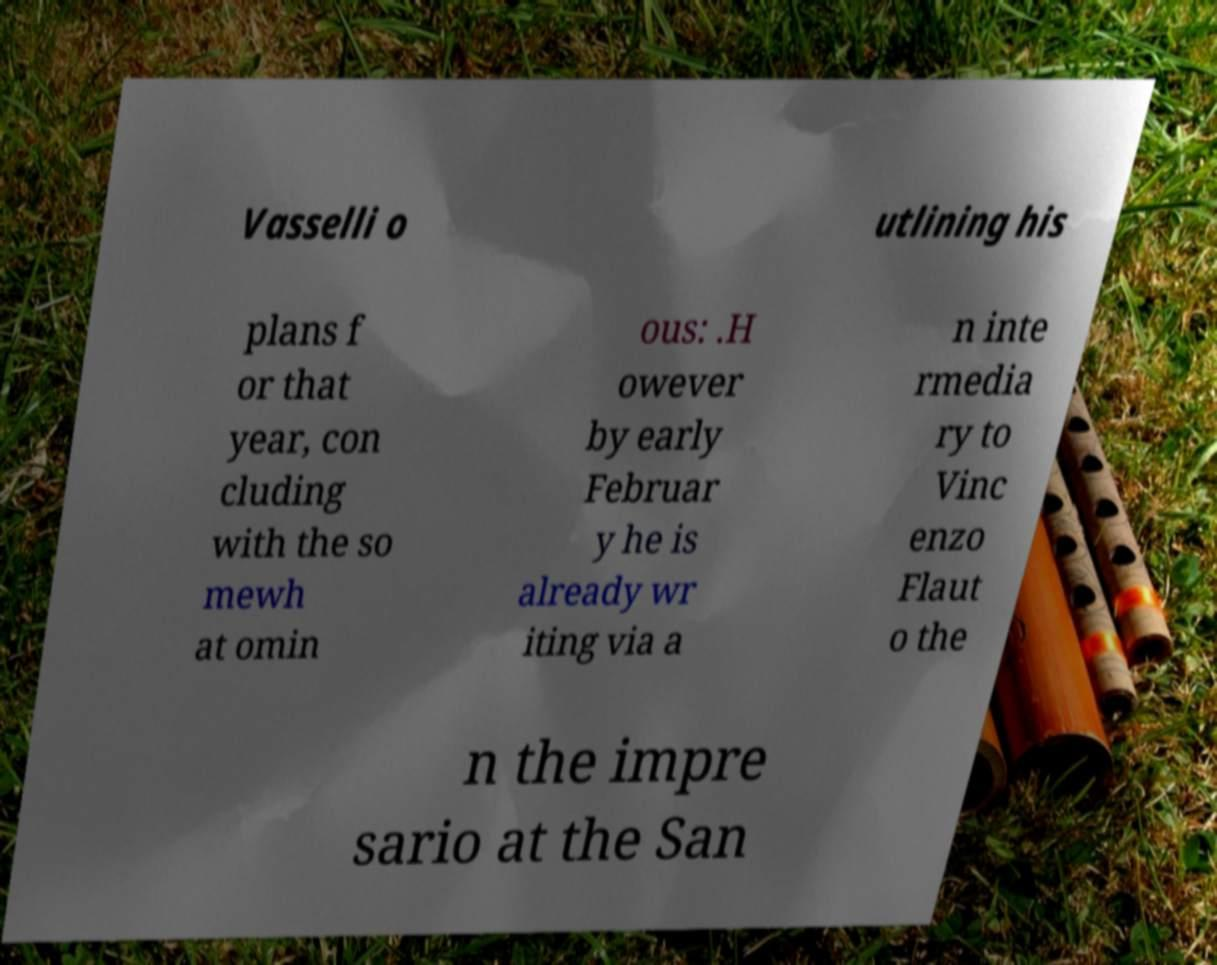Please identify and transcribe the text found in this image. Vasselli o utlining his plans f or that year, con cluding with the so mewh at omin ous: .H owever by early Februar y he is already wr iting via a n inte rmedia ry to Vinc enzo Flaut o the n the impre sario at the San 